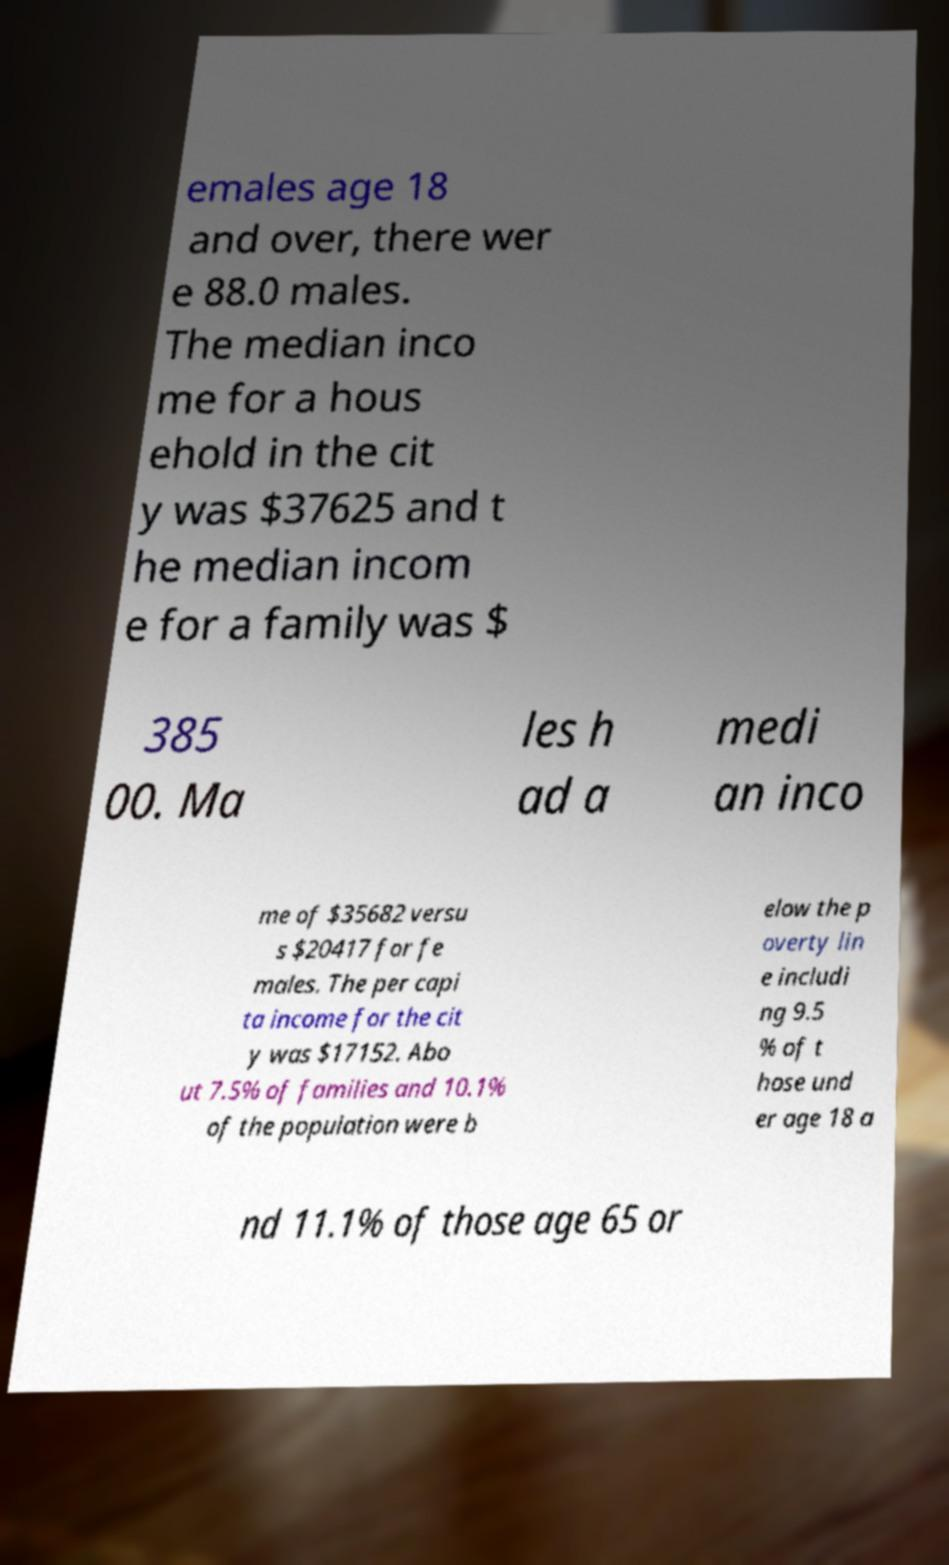Please identify and transcribe the text found in this image. emales age 18 and over, there wer e 88.0 males. The median inco me for a hous ehold in the cit y was $37625 and t he median incom e for a family was $ 385 00. Ma les h ad a medi an inco me of $35682 versu s $20417 for fe males. The per capi ta income for the cit y was $17152. Abo ut 7.5% of families and 10.1% of the population were b elow the p overty lin e includi ng 9.5 % of t hose und er age 18 a nd 11.1% of those age 65 or 